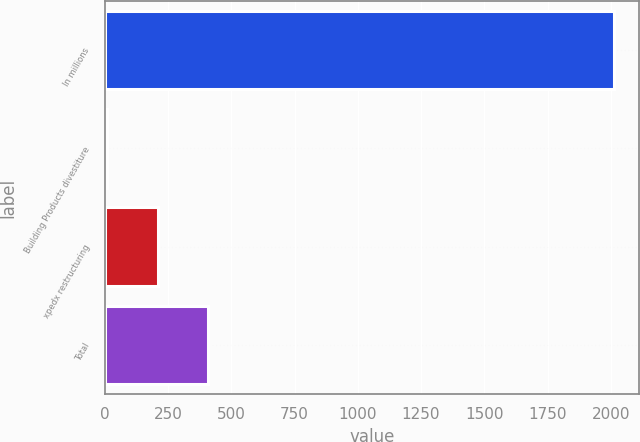Convert chart. <chart><loc_0><loc_0><loc_500><loc_500><bar_chart><fcel>In millions<fcel>Building Products divestiture<fcel>xpedx restructuring<fcel>Total<nl><fcel>2012<fcel>9<fcel>209.3<fcel>409.6<nl></chart> 